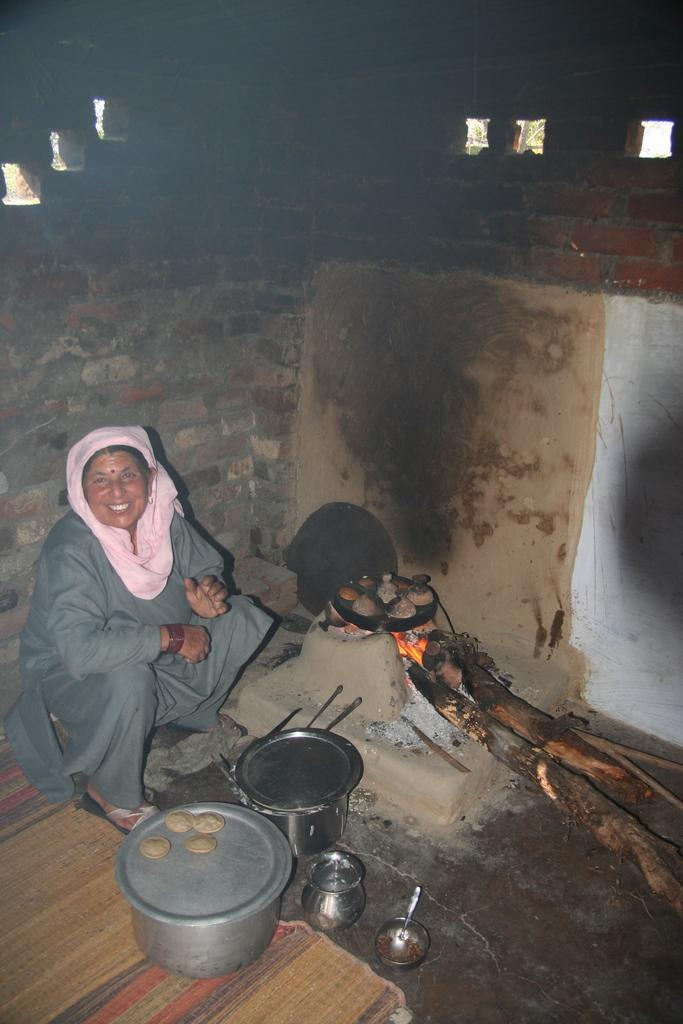What is the woman doing in the image? The woman is sitting in the image. What can be seen near the woman? There is a wood stove and a pan with food in the image. What type of containers are present in the image? There are bowls in the image. What is visible in the background of the image? There is a wall in the background of the image. What advice is the woman's grandfather giving her in the image? There is no grandfather present in the image, so no advice can be given. What type of insects can be seen crawling on the food in the image? There are no insects, such as ants, present in the image. What type of farm equipment is visible in the image? There is no farm equipment, such as a scarecrow, present in the image. 